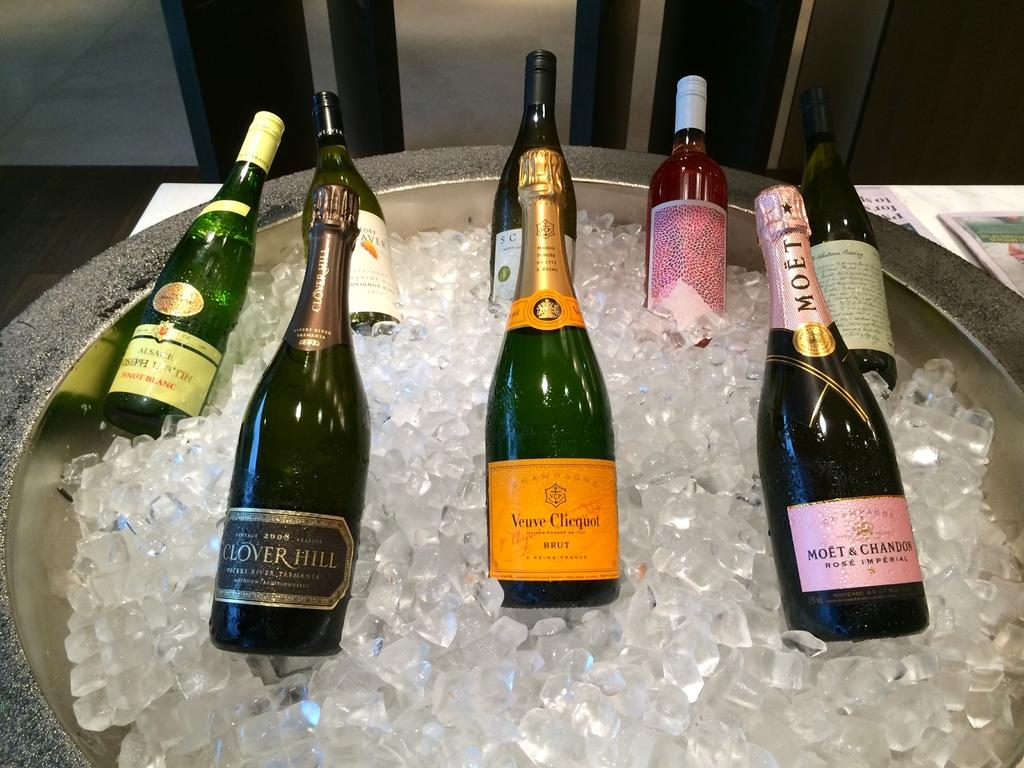<image>
Write a terse but informative summary of the picture. A botlte of Clover Hill wine from 2008 is on ice with some other bottles. 